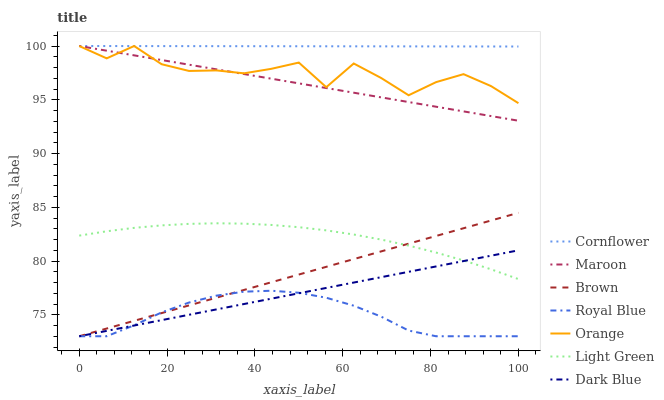Does Royal Blue have the minimum area under the curve?
Answer yes or no. Yes. Does Cornflower have the maximum area under the curve?
Answer yes or no. Yes. Does Brown have the minimum area under the curve?
Answer yes or no. No. Does Brown have the maximum area under the curve?
Answer yes or no. No. Is Dark Blue the smoothest?
Answer yes or no. Yes. Is Orange the roughest?
Answer yes or no. Yes. Is Brown the smoothest?
Answer yes or no. No. Is Brown the roughest?
Answer yes or no. No. Does Brown have the lowest value?
Answer yes or no. Yes. Does Maroon have the lowest value?
Answer yes or no. No. Does Orange have the highest value?
Answer yes or no. Yes. Does Brown have the highest value?
Answer yes or no. No. Is Brown less than Orange?
Answer yes or no. Yes. Is Cornflower greater than Brown?
Answer yes or no. Yes. Does Cornflower intersect Maroon?
Answer yes or no. Yes. Is Cornflower less than Maroon?
Answer yes or no. No. Is Cornflower greater than Maroon?
Answer yes or no. No. Does Brown intersect Orange?
Answer yes or no. No. 